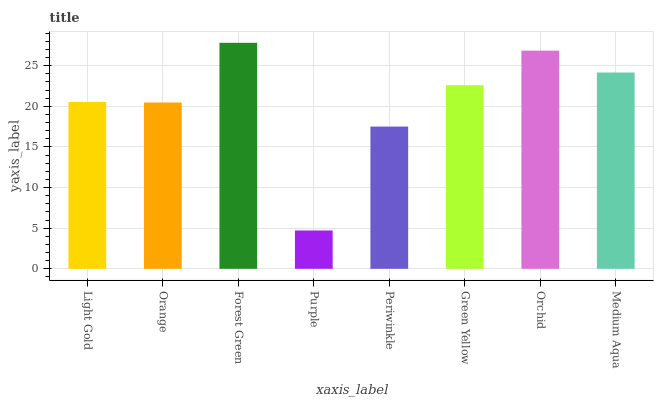Is Orange the minimum?
Answer yes or no. No. Is Orange the maximum?
Answer yes or no. No. Is Light Gold greater than Orange?
Answer yes or no. Yes. Is Orange less than Light Gold?
Answer yes or no. Yes. Is Orange greater than Light Gold?
Answer yes or no. No. Is Light Gold less than Orange?
Answer yes or no. No. Is Green Yellow the high median?
Answer yes or no. Yes. Is Light Gold the low median?
Answer yes or no. Yes. Is Light Gold the high median?
Answer yes or no. No. Is Orange the low median?
Answer yes or no. No. 